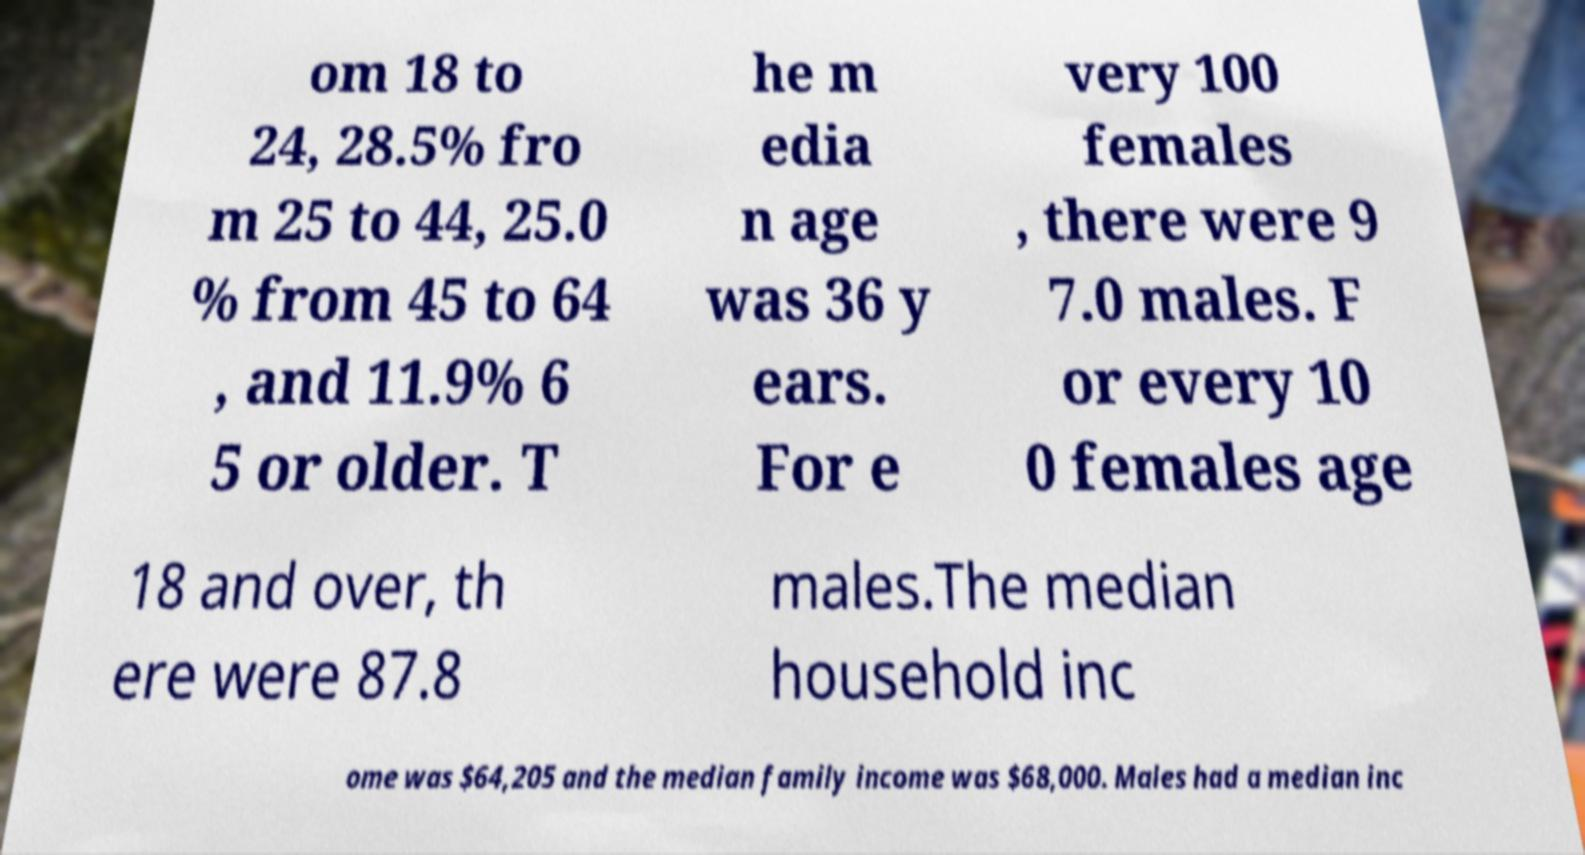Can you accurately transcribe the text from the provided image for me? om 18 to 24, 28.5% fro m 25 to 44, 25.0 % from 45 to 64 , and 11.9% 6 5 or older. T he m edia n age was 36 y ears. For e very 100 females , there were 9 7.0 males. F or every 10 0 females age 18 and over, th ere were 87.8 males.The median household inc ome was $64,205 and the median family income was $68,000. Males had a median inc 